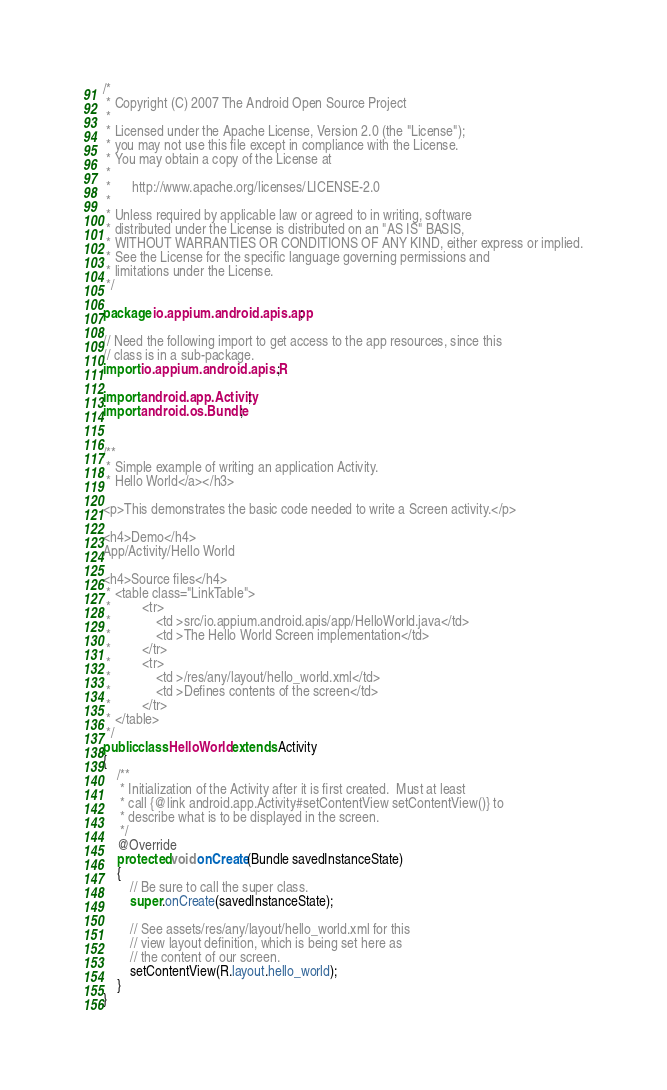<code> <loc_0><loc_0><loc_500><loc_500><_Java_>/*
 * Copyright (C) 2007 The Android Open Source Project
 *
 * Licensed under the Apache License, Version 2.0 (the "License");
 * you may not use this file except in compliance with the License.
 * You may obtain a copy of the License at
 *
 *      http://www.apache.org/licenses/LICENSE-2.0
 *
 * Unless required by applicable law or agreed to in writing, software
 * distributed under the License is distributed on an "AS IS" BASIS,
 * WITHOUT WARRANTIES OR CONDITIONS OF ANY KIND, either express or implied.
 * See the License for the specific language governing permissions and
 * limitations under the License.
 */

package io.appium.android.apis.app;

// Need the following import to get access to the app resources, since this
// class is in a sub-package.
import io.appium.android.apis.R;

import android.app.Activity;
import android.os.Bundle;


/**
 * Simple example of writing an application Activity.
 * Hello World</a></h3>

<p>This demonstrates the basic code needed to write a Screen activity.</p>

<h4>Demo</h4>
App/Activity/Hello World
 
<h4>Source files</h4>
 * <table class="LinkTable">
 *         <tr>
 *             <td >src/io.appium.android.apis/app/HelloWorld.java</td>
 *             <td >The Hello World Screen implementation</td>
 *         </tr>
 *         <tr>
 *             <td >/res/any/layout/hello_world.xml</td>
 *             <td >Defines contents of the screen</td>
 *         </tr>
 * </table> 
 */
public class HelloWorld extends Activity
{
    /**
     * Initialization of the Activity after it is first created.  Must at least
     * call {@link android.app.Activity#setContentView setContentView()} to
     * describe what is to be displayed in the screen.
     */
    @Override
	protected void onCreate(Bundle savedInstanceState)
    {
        // Be sure to call the super class.
        super.onCreate(savedInstanceState);

        // See assets/res/any/layout/hello_world.xml for this
        // view layout definition, which is being set here as
        // the content of our screen.
        setContentView(R.layout.hello_world);
    }
}
</code> 